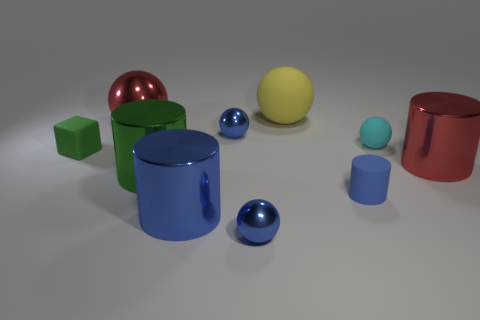What materials do the objects in the image look like they're made of? The objects exhibit various specular reflections suggesting they are rendered with materials similar to metals and plastics, providing a somewhat realistic depiction of these materials in a 3D modeled environment. 